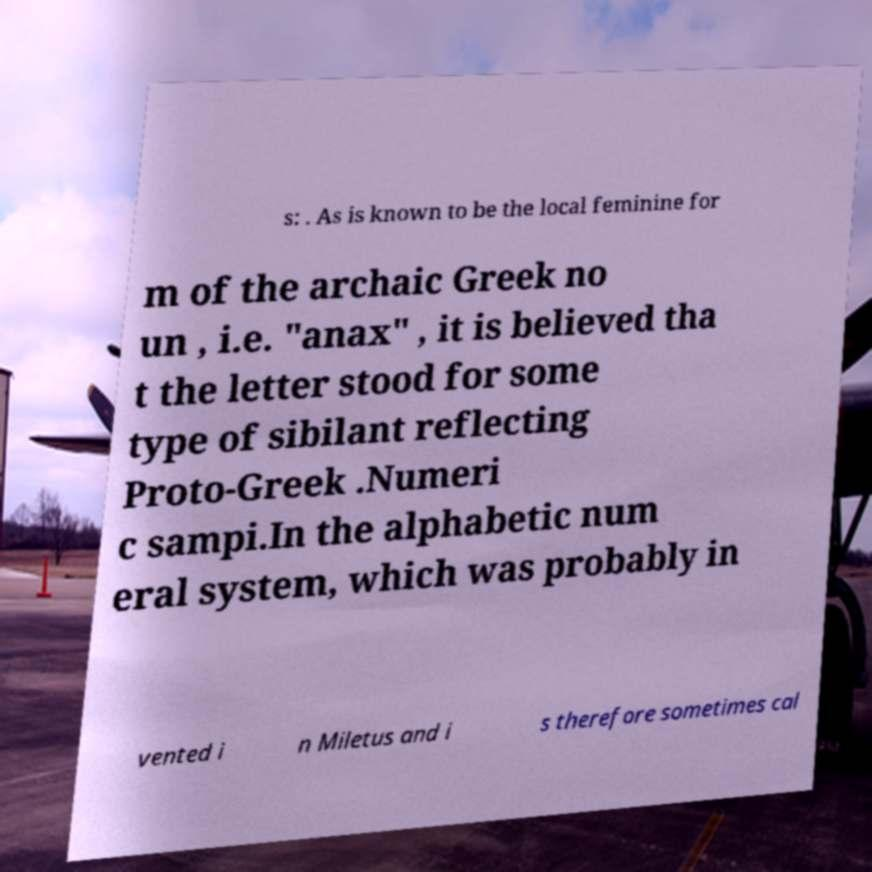For documentation purposes, I need the text within this image transcribed. Could you provide that? s: . As is known to be the local feminine for m of the archaic Greek no un , i.e. "anax" , it is believed tha t the letter stood for some type of sibilant reflecting Proto-Greek .Numeri c sampi.In the alphabetic num eral system, which was probably in vented i n Miletus and i s therefore sometimes cal 